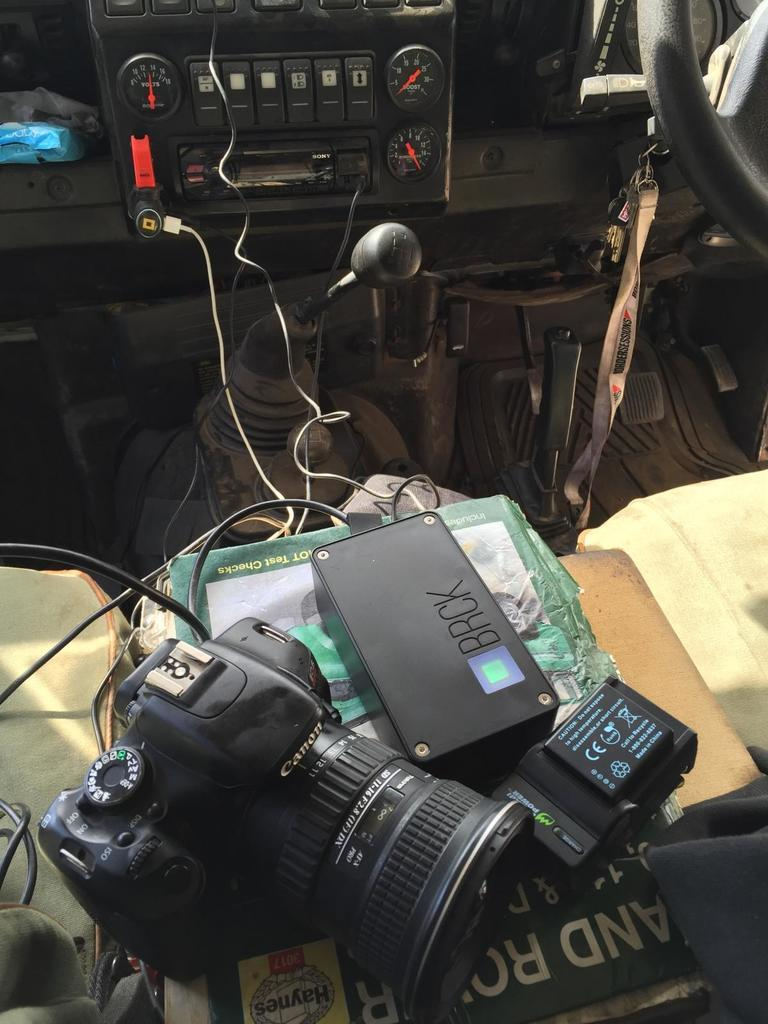Where was the image taken? The image was taken inside a vehicle. What can be seen in the image besides the interior of the vehicle? There is a camera and a battery in the image. What is placed on the seat in the image? There is an object placed on the seat in the image. What else can be seen in the image? Wires are visible in the image. What type of polish is being applied to the son's shoes in the image? There is no son or shoes present in the image, and therefore no polish application can be observed. 